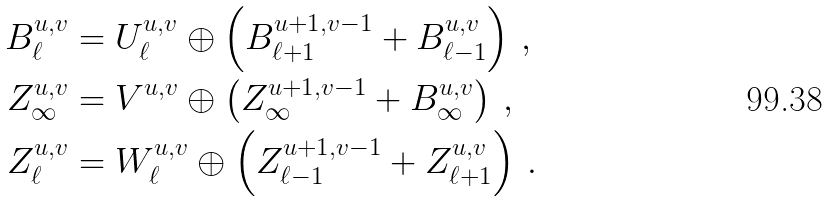Convert formula to latex. <formula><loc_0><loc_0><loc_500><loc_500>B _ { \ell } ^ { u , v } & = U _ { \ell } ^ { u , v } \oplus \left ( B _ { \ell + 1 } ^ { u + 1 , v - 1 } + B _ { \ell - 1 } ^ { u , v } \right ) \, , \\ Z _ { \infty } ^ { u , v } & = V ^ { u , v } \oplus \left ( Z _ { \infty } ^ { u + 1 , v - 1 } + B _ { \infty } ^ { u , v } \right ) \, , \\ Z _ { \ell } ^ { u , v } & = W _ { \ell } ^ { u , v } \oplus \left ( Z _ { \ell - 1 } ^ { u + 1 , v - 1 } + Z _ { \ell + 1 } ^ { u , v } \right ) \, .</formula> 